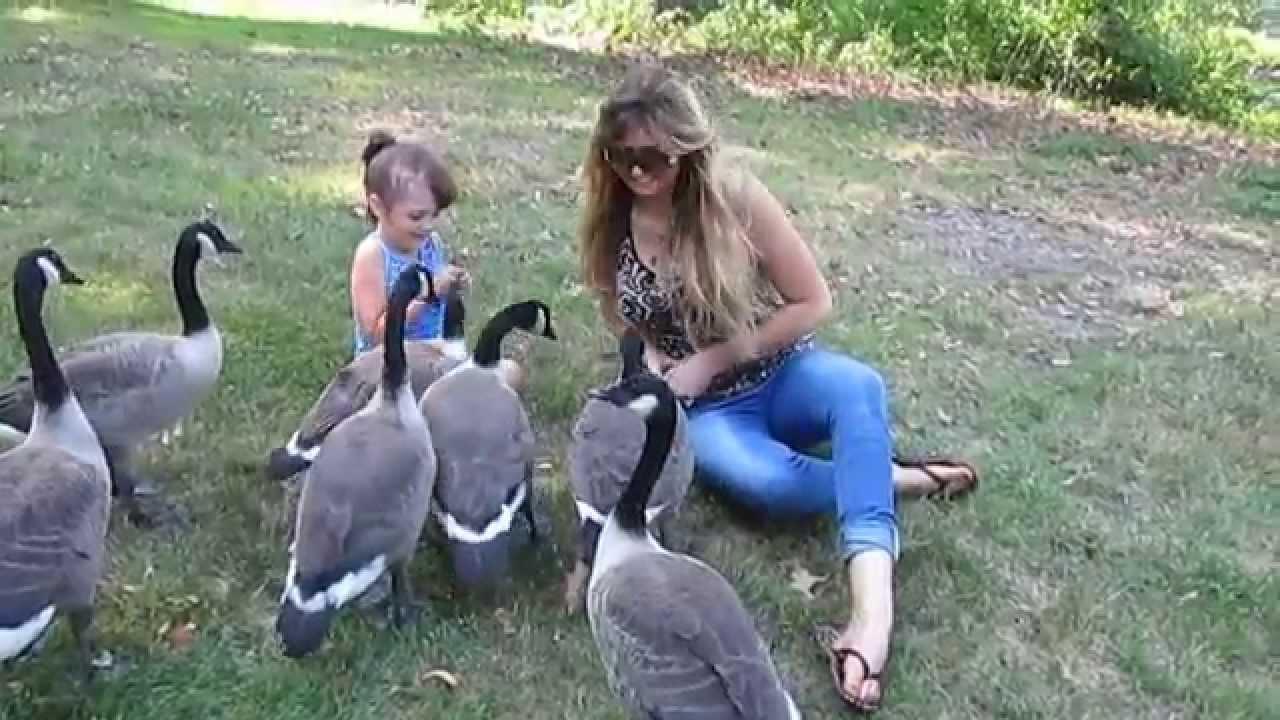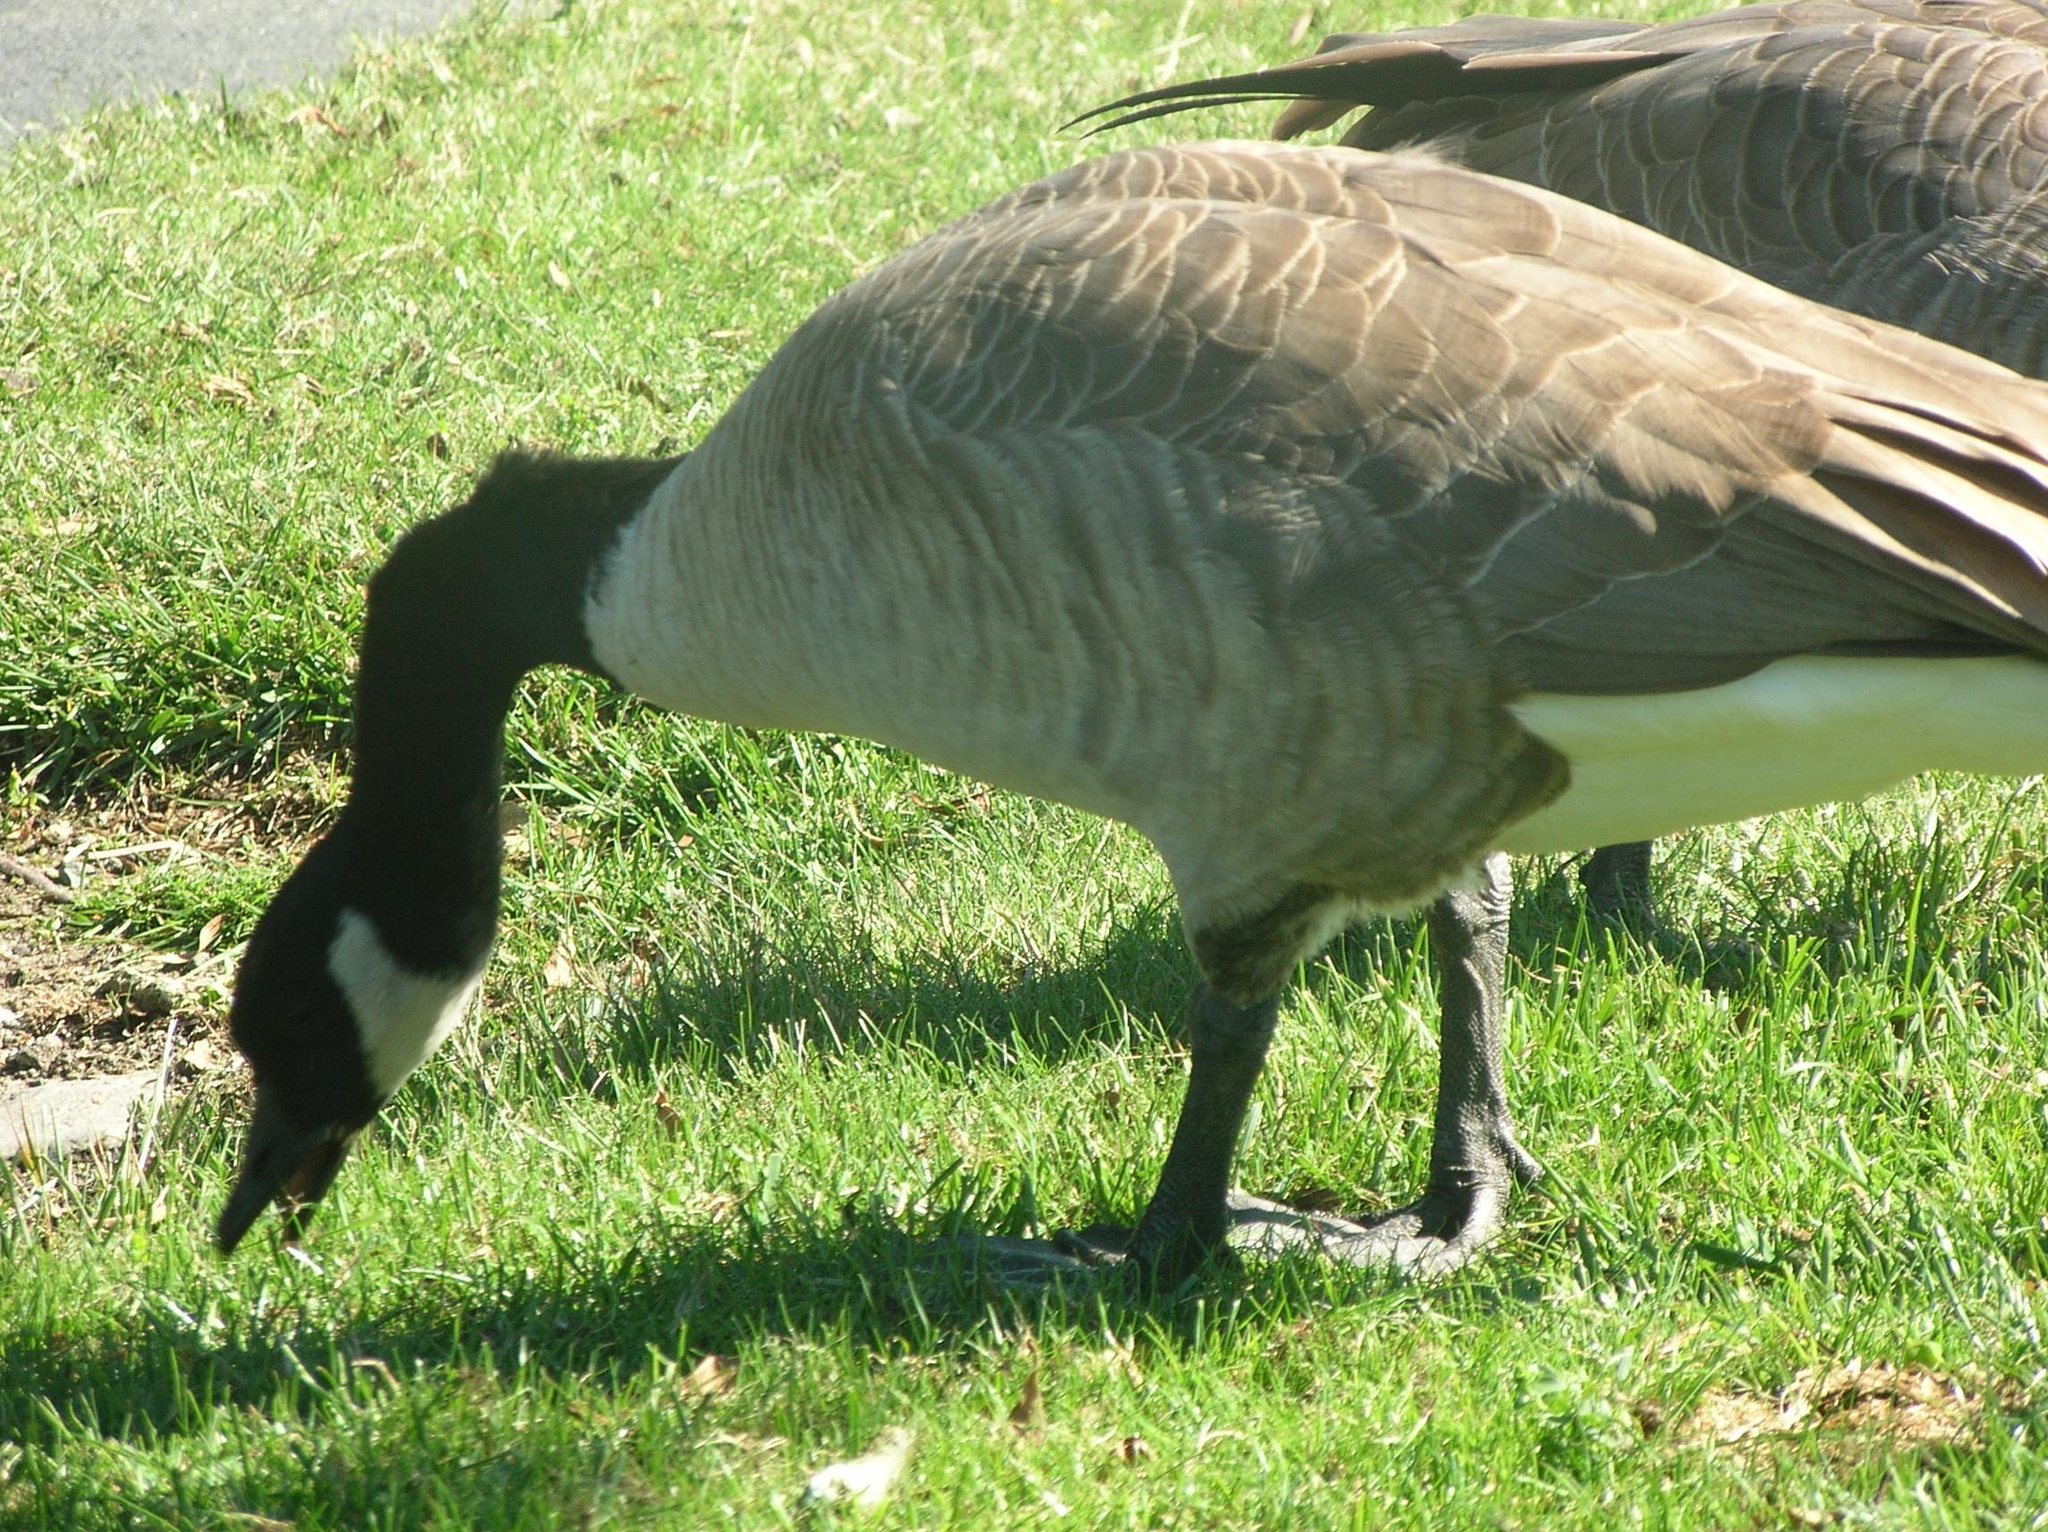The first image is the image on the left, the second image is the image on the right. Considering the images on both sides, is "In one of the image the geese are in the water." valid? Answer yes or no. No. The first image is the image on the left, the second image is the image on the right. Examine the images to the left and right. Is the description "There is a single black and gray goose grazing in the grass." accurate? Answer yes or no. Yes. 